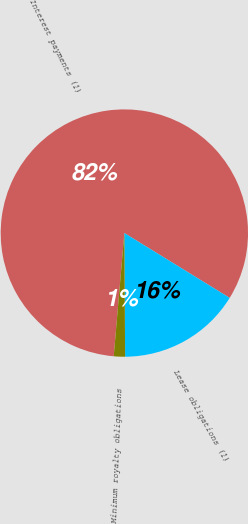Convert chart to OTSL. <chart><loc_0><loc_0><loc_500><loc_500><pie_chart><fcel>Interest payments (1)<fcel>Lease obligations (1)<fcel>Minimum royalty obligations<nl><fcel>82.42%<fcel>16.12%<fcel>1.47%<nl></chart> 